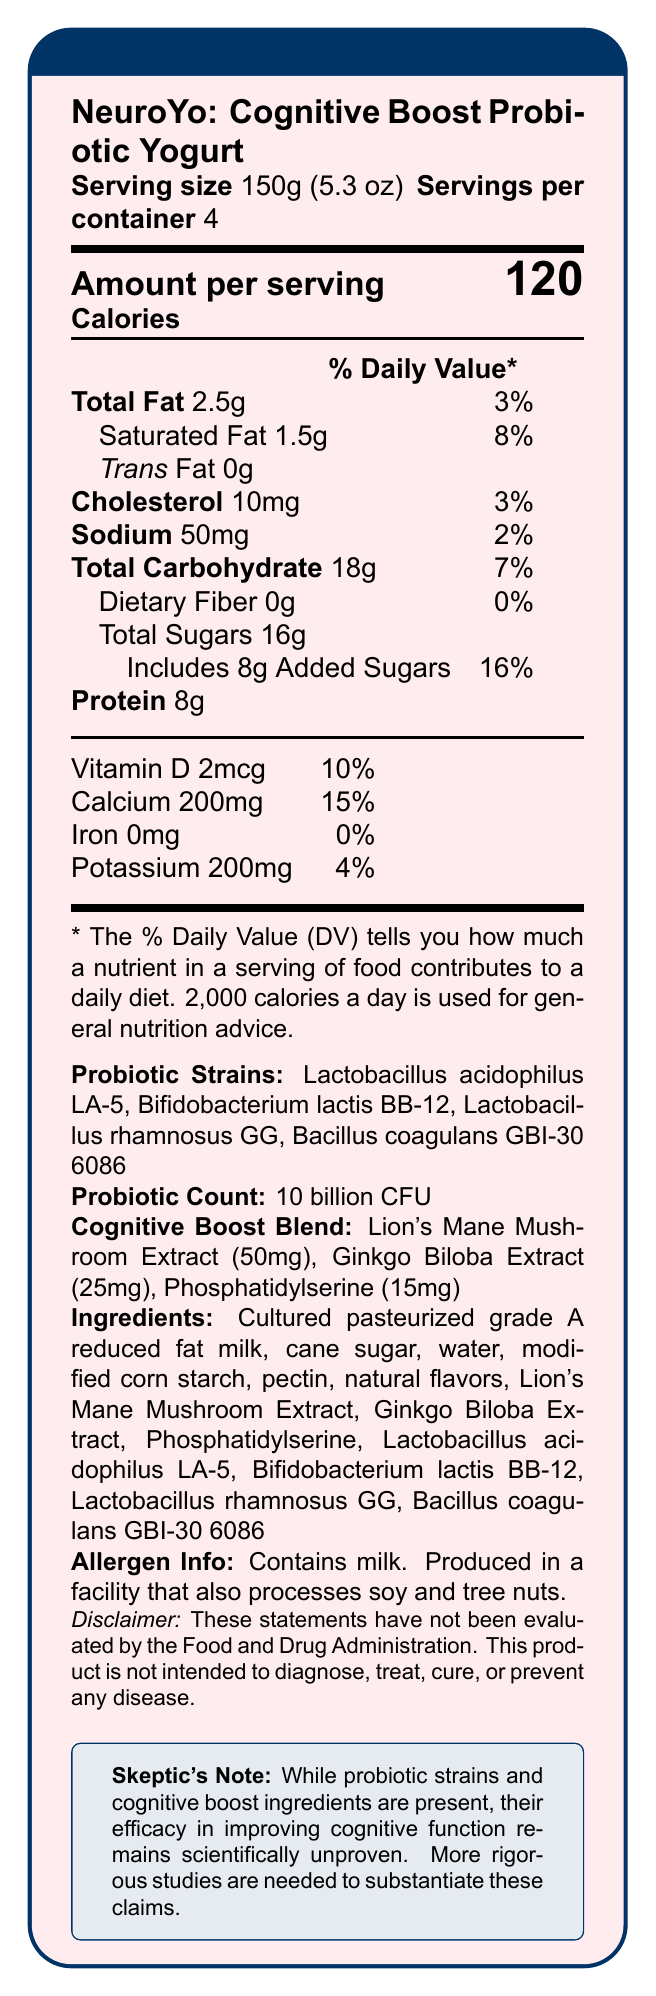What is the serving size of NeuroYo? The serving size is explicitly mentioned as 150g (5.3 oz) in the document.
Answer: 150g (5.3 oz) How many servings are there per container of NeuroYo? The document states that there are 4 servings per container.
Answer: 4 How much saturated fat is in one serving of NeuroYo? The amount of saturated fat per serving is indicated as 1.5g.
Answer: 1.5g What is the calorie count per serving of NeuroYo? The document clearly states that there are 120 calories per serving.
Answer: 120 What is the primary source of added sugars in NeuroYo? The ingredients list includes "cane sugar" as the primary source of added sugars.
Answer: Cane sugar Which probiotic strain is NOT listed in NeuroYo? A. Lactobacillus acidophilus LA-5 B. Bifidobacterium lactis BB-12 C. Streptococcus thermophilus D. Bacillus coagulans GBI-30 6086 Streptococcus thermophilus is not listed among the probiotic strains in the document.
Answer: C. Streptococcus thermophilus How much Vitamin D is in one serving of NeuroYo? A. 1mcg B. 2mcg C. 3mcg D. 4mcg The document mentions that one serving contains 2mcg of Vitamin D.
Answer: B. 2mcg Does NeuroYo contain any iron? The iron content is listed as 0mg, indicating that there is no iron in a serving of NeuroYo.
Answer: No Is the sodium content in NeuroYo high? With only 50mg of sodium per serving (2% of the daily value), the sodium content is low.
Answer: No Summarize the main idea of the document. The document provides comprehensive nutritional information for NeuroYo, a yogurt that claims to improve cognitive function. It includes details on calories, fats, sugars, probiotics, cognitive-boosting ingredients, and allergen warnings, along with a skeptic’s note regarding the efficacy of cognitive benefits.
Answer: The main idea of the document is to present the Nutrition Facts of NeuroYo: Cognitive Boost Probiotic Yogurt, detailing its serving size, nutritional content, probiotic strains, cognitive boost blend, ingredients, allergen information, and a disclaimer regarding the claims about cognitive benefits. Is the efficacy of the cognitive boost blend proven scientifically? The skeptic's note in the document states that the efficacy of the cognitive boost ingredients in improving cognitive function remains scientifically unproven, and more rigorous studies are needed.
Answer: No What are the benefits claimed by the 'Cognitive Boost Blend'? The blend claims to enhance cognitive function, as implied by the product name and details provided.
Answer: Cognitive benefits What is the total amount of added sugars in a container of NeuroYo? Since there are 4 servings per container and each serving contains 8g of added sugars, the total amount is 4 x 8g = 32g.
Answer: 32g How much protein is in one serving of NeuroYo? The document lists the protein content as 8g per serving.
Answer: 8g What is the combined weight of Lion's Mane Mushroom Extract and Ginkgo Biloba Extract in the cognitive boost blend? The weight of Lion's Mane Mushroom Extract is 50mg and Ginkgo Biloba Extract is 25mg, totaling 50mg + 25mg = 75mg.
Answer: 75mg What percentage of the daily value for calcium does one serving of NeuroYo provide? According to the document, one serving provides 15% of the daily value for calcium.
Answer: 15% Can you determine the exact population this product is most suitable for from the document? The document provides nutritional information and claims but does not specify the target population for this product.
Answer: Not enough information 